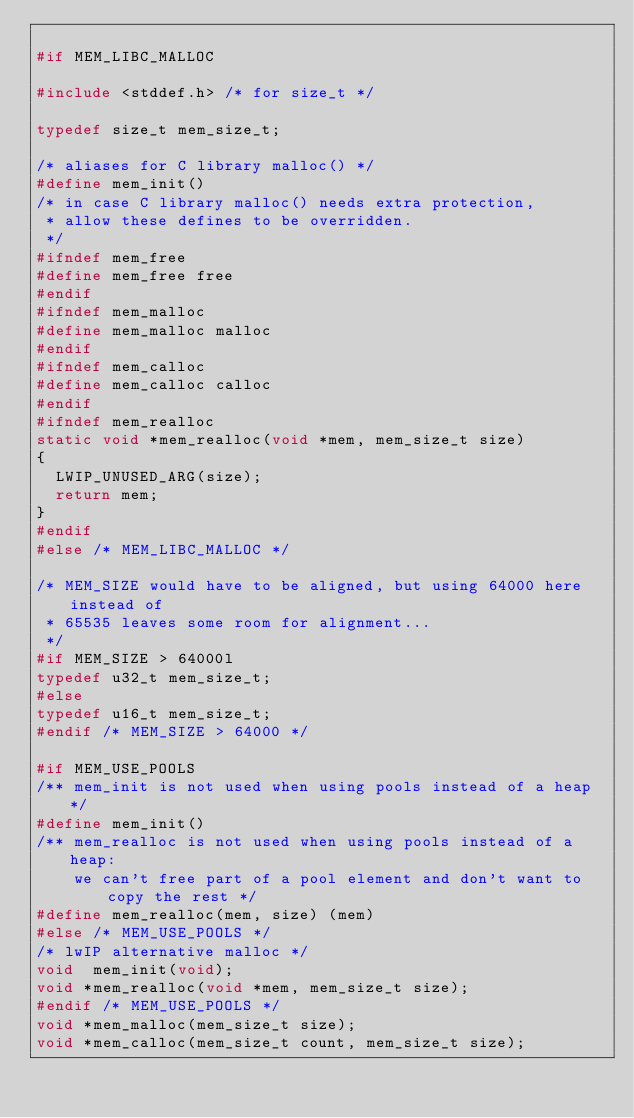<code> <loc_0><loc_0><loc_500><loc_500><_C_>
#if MEM_LIBC_MALLOC

#include <stddef.h> /* for size_t */

typedef size_t mem_size_t;

/* aliases for C library malloc() */
#define mem_init()
/* in case C library malloc() needs extra protection,
 * allow these defines to be overridden.
 */
#ifndef mem_free
#define mem_free free
#endif
#ifndef mem_malloc
#define mem_malloc malloc
#endif
#ifndef mem_calloc
#define mem_calloc calloc
#endif
#ifndef mem_realloc
static void *mem_realloc(void *mem, mem_size_t size)
{
  LWIP_UNUSED_ARG(size);
  return mem;
}
#endif
#else /* MEM_LIBC_MALLOC */

/* MEM_SIZE would have to be aligned, but using 64000 here instead of
 * 65535 leaves some room for alignment...
 */
#if MEM_SIZE > 64000l
typedef u32_t mem_size_t;
#else
typedef u16_t mem_size_t;
#endif /* MEM_SIZE > 64000 */

#if MEM_USE_POOLS
/** mem_init is not used when using pools instead of a heap */
#define mem_init()
/** mem_realloc is not used when using pools instead of a heap:
    we can't free part of a pool element and don't want to copy the rest */
#define mem_realloc(mem, size) (mem)
#else /* MEM_USE_POOLS */
/* lwIP alternative malloc */
void  mem_init(void);
void *mem_realloc(void *mem, mem_size_t size);
#endif /* MEM_USE_POOLS */
void *mem_malloc(mem_size_t size);
void *mem_calloc(mem_size_t count, mem_size_t size);</code> 